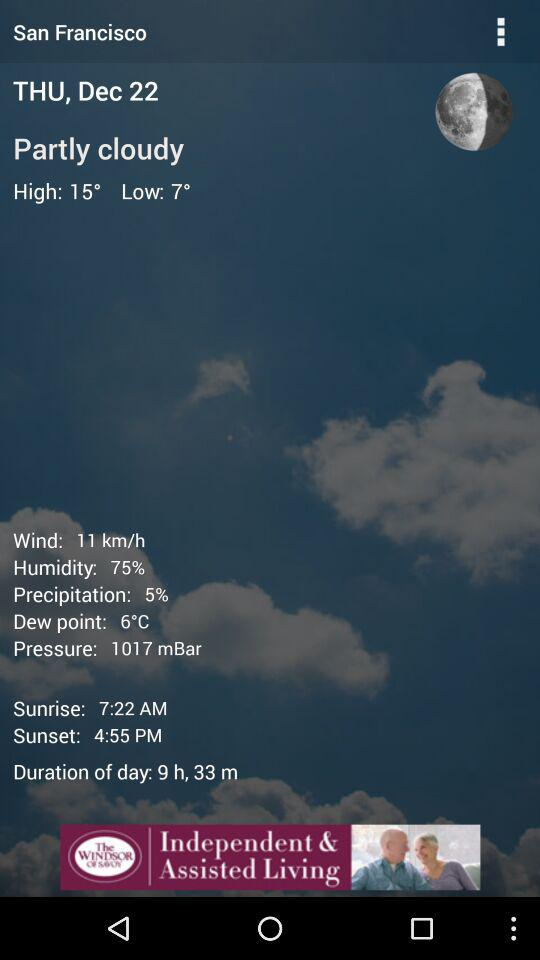What is the speed of the wind? The speed of the wind is 11 kilometres per hour. 